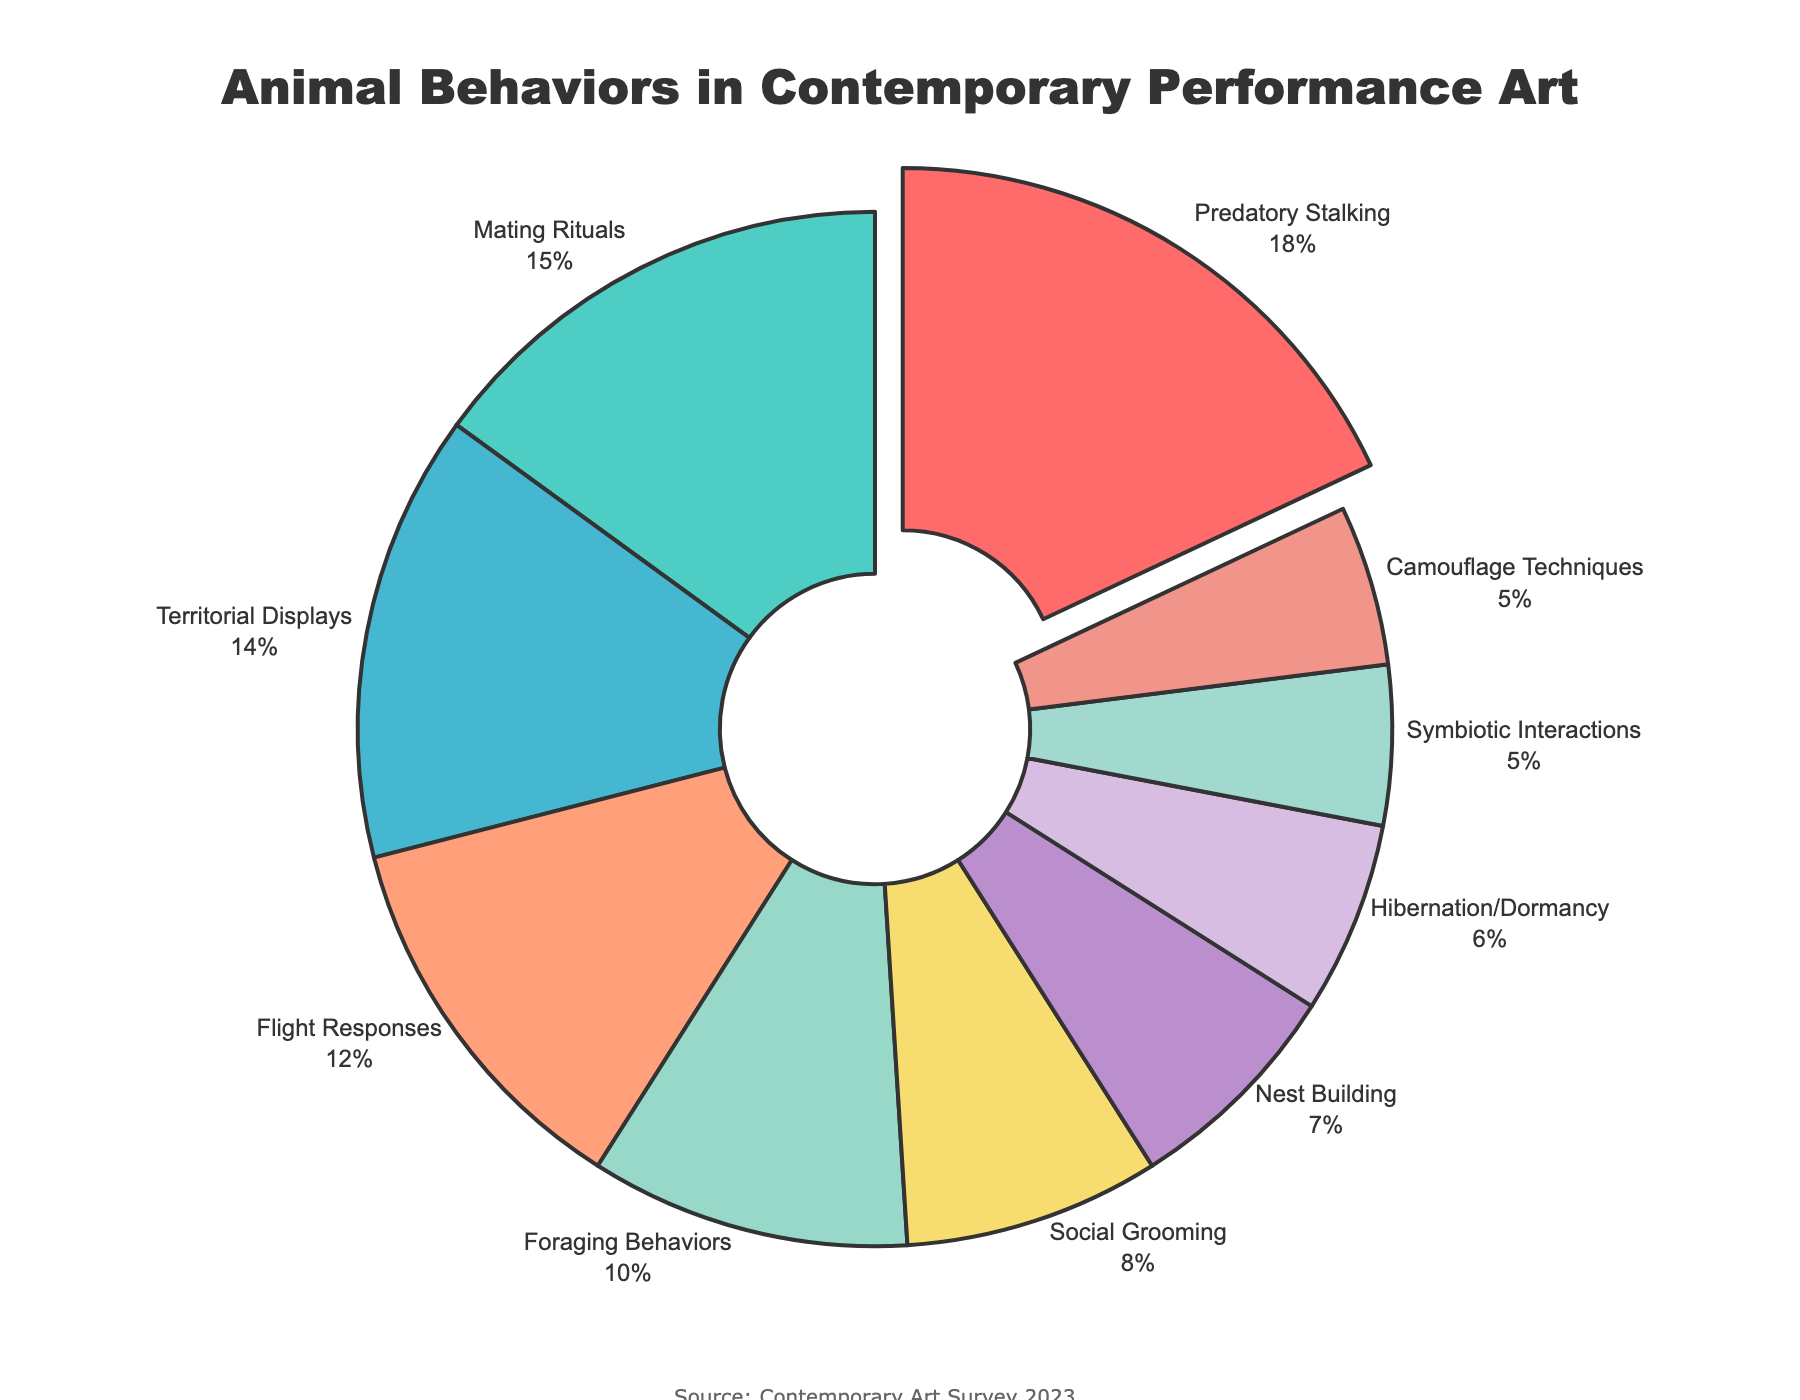What animal behavior is most frequently portrayed in contemporary performance art? The section with the largest percentage represents the most frequently portrayed behavior. In this case, "Predatory Stalking" is the largest section.
Answer: Predatory Stalking What percentage of portrayed behaviors are related to social interactions (Social Grooming and Symbiotic Interactions combined)? Add the percentages of Social Grooming and Symbiotic Interactions. Social Grooming is 8% and Symbiotic Interactions is 5%. 8% + 5% = 13%.
Answer: 13% How does the percentage of foraging behaviors compare to nest building behaviors? Identify the percentages for both behaviors. Foraging Behaviors is 10% and Nest Building is 7%. Foraging Behaviors has a higher percentage than Nest Building.
Answer: Foraging Behaviors is higher What is the combined percentage of Territorial Displays, Flight Responses, and Hibernation/Dormancy? Add the percentages of Territorial Displays, Flight Responses, and Hibernation/Dormancy. Territorial Displays is 14%, Flight Responses is 12%, and Hibernation/Dormancy is 6%. 14% + 12% + 6% = 32%.
Answer: 32% Which visual attribute is unique to "Predatory Stalking" in the pie chart? Observe the visual attributes of all segments in the pie chart. The "Predatory Stalking" section is slightly pulled out from the pie, making it unique.
Answer: Pulled out segment How much more frequent are Mating Rituals compared to Camouflage Techniques? Find the difference in the percentages of Mating Rituals and Camouflage Techniques. Mating Rituals is 15% and Camouflage Techniques is 5%. 15% - 5% = 10%.
Answer: 10% Which behavior has the smallest percentage representation in contemporary performance art? Identify the section with the smallest percentage. Both Symbiotic Interactions and Camouflage Techniques share the smallest value at 5%.
Answer: Symbiotic Interactions or Camouflage Techniques What's the difference in percentage between the most and least frequently portrayed behaviors? Subtract the percentage of the least frequently portrayed behavior from the most frequently portrayed behavior. The most frequent is Predatory Stalking at 18% and the least is either Symbiotic Interactions or Camouflage Techniques at 5%. 18% - 5% = 13%.
Answer: 13% How do the Flight Responses and Territorial Displays compare in terms of percentage? Compare the two percentages. Flight Responses is 12% and Territorial Displays is 14%. Territorial Displays has a higher percentage than Flight Responses.
Answer: Territorial Displays is higher 